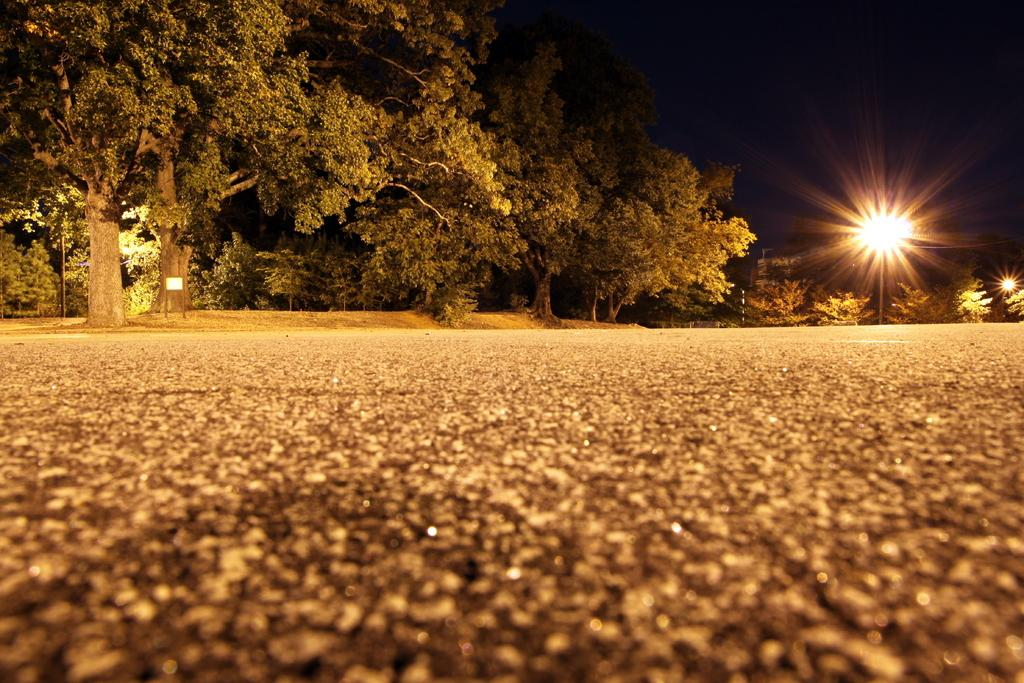What is the main feature of the image? There is a road in the image. Are there any other elements visible along the road? Yes, there are lights and trees in the image. Can you describe the objects present in the image? There are some objects in the image, but their specific nature is not mentioned in the facts. What can be seen at the top of the image? The top of the image has a dark view. Can you hear the bears laughing while looking at the egg in the image? There are no bears, laughter, or eggs present in the image. 